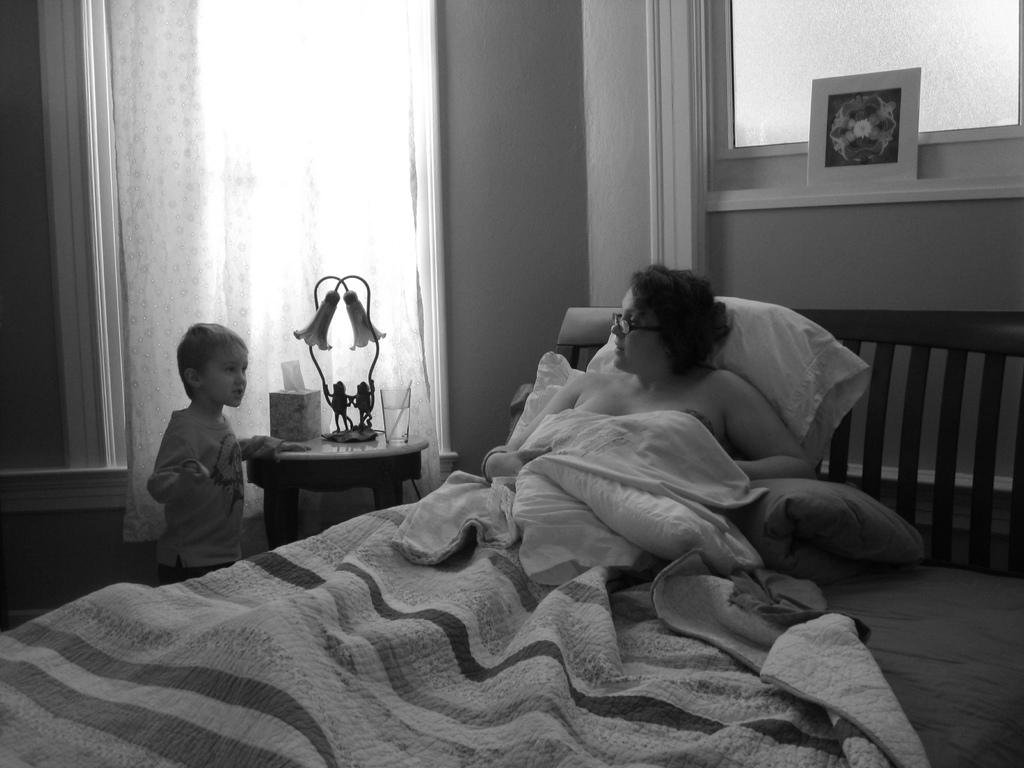What is the person in the image doing? There is a person lying on the bed in the image. Who else is present in the room? There is a boy standing near the bed. What piece of furniture is in the room that can be used for sitting? A stool is present in the room. What is on top of the stool? The stool has a lamp and a glass on it. What can be seen behind the lamp on the stool? There are curtains behind the lamp. How many jellyfish are swimming in the glass on the stool? There are no jellyfish present in the image, and the glass on the stool does not contain any water or aquatic creatures. 